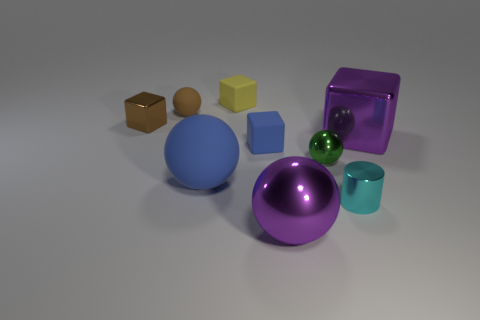Subtract all tiny blocks. How many blocks are left? 1 Subtract all brown cubes. How many cubes are left? 3 Add 1 tiny brown metal objects. How many objects exist? 10 Subtract 2 blocks. How many blocks are left? 2 Subtract all yellow balls. Subtract all gray cylinders. How many balls are left? 4 Subtract all spheres. How many objects are left? 5 Add 8 small blue rubber blocks. How many small blue rubber blocks are left? 9 Add 2 tiny green spheres. How many tiny green spheres exist? 3 Subtract 1 purple blocks. How many objects are left? 8 Subtract all blue blocks. Subtract all blue objects. How many objects are left? 6 